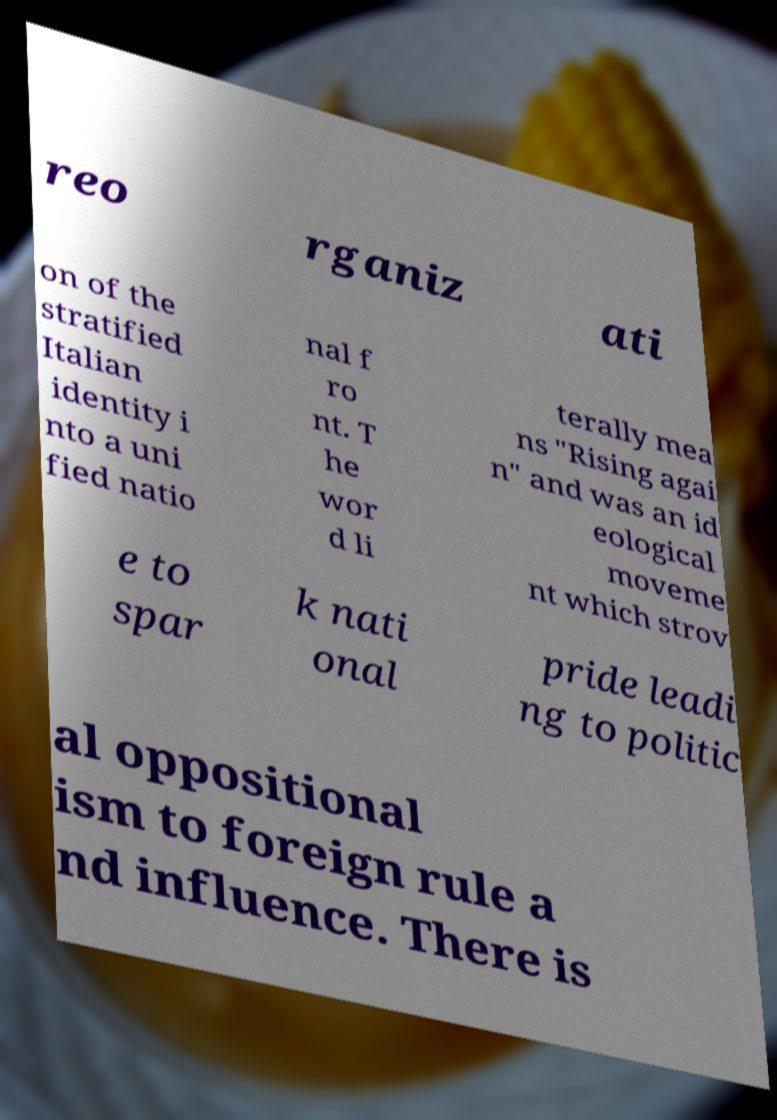Please read and relay the text visible in this image. What does it say? reo rganiz ati on of the stratified Italian identity i nto a uni fied natio nal f ro nt. T he wor d li terally mea ns "Rising agai n" and was an id eological moveme nt which strov e to spar k nati onal pride leadi ng to politic al oppositional ism to foreign rule a nd influence. There is 